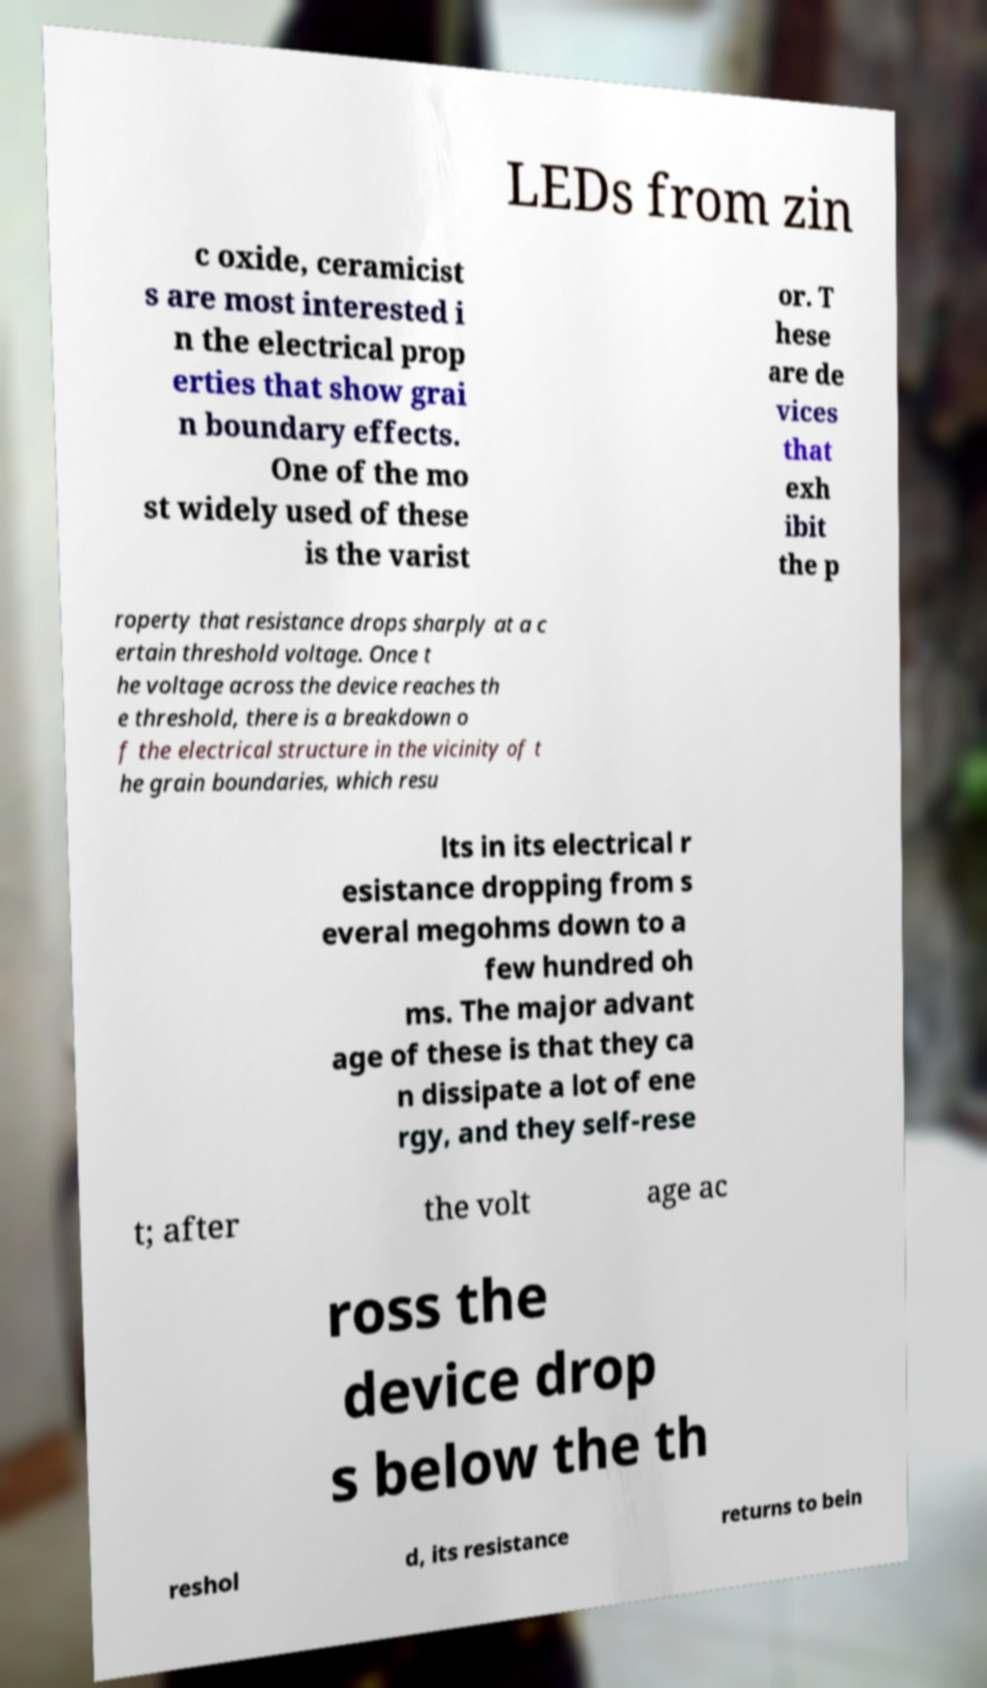There's text embedded in this image that I need extracted. Can you transcribe it verbatim? LEDs from zin c oxide, ceramicist s are most interested i n the electrical prop erties that show grai n boundary effects. One of the mo st widely used of these is the varist or. T hese are de vices that exh ibit the p roperty that resistance drops sharply at a c ertain threshold voltage. Once t he voltage across the device reaches th e threshold, there is a breakdown o f the electrical structure in the vicinity of t he grain boundaries, which resu lts in its electrical r esistance dropping from s everal megohms down to a few hundred oh ms. The major advant age of these is that they ca n dissipate a lot of ene rgy, and they self-rese t; after the volt age ac ross the device drop s below the th reshol d, its resistance returns to bein 